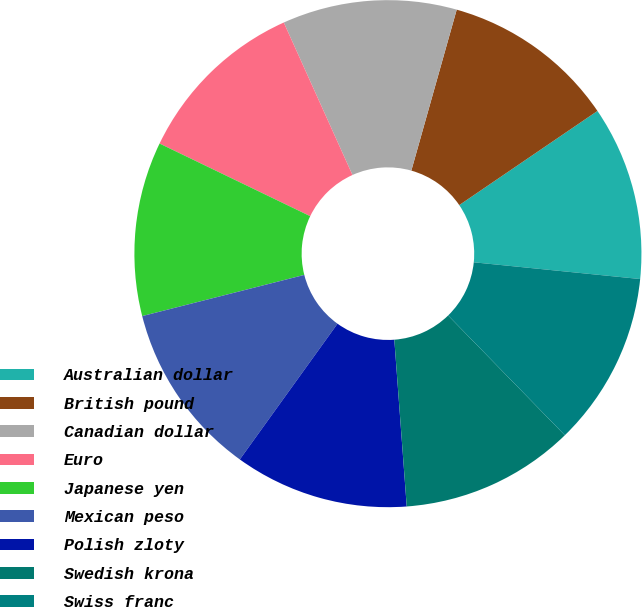Convert chart. <chart><loc_0><loc_0><loc_500><loc_500><pie_chart><fcel>Australian dollar<fcel>British pound<fcel>Canadian dollar<fcel>Euro<fcel>Japanese yen<fcel>Mexican peso<fcel>Polish zloty<fcel>Swedish krona<fcel>Swiss franc<nl><fcel>11.11%<fcel>11.11%<fcel>11.11%<fcel>11.11%<fcel>11.11%<fcel>11.11%<fcel>11.11%<fcel>11.11%<fcel>11.11%<nl></chart> 